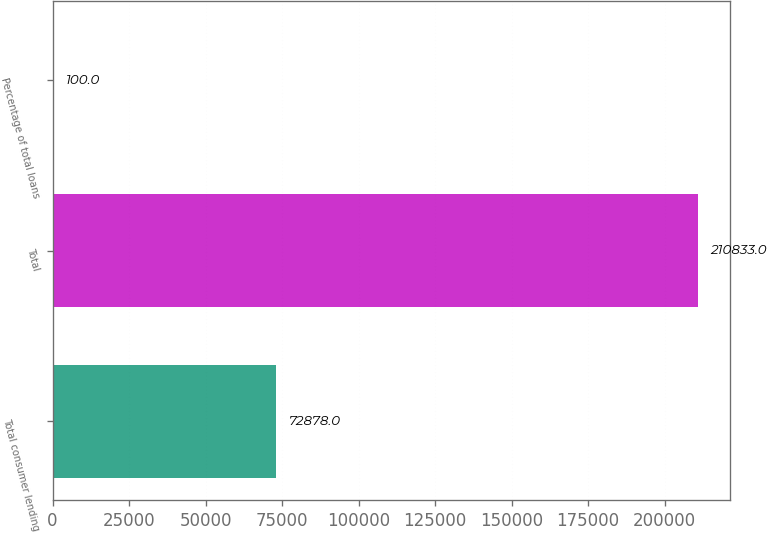Convert chart to OTSL. <chart><loc_0><loc_0><loc_500><loc_500><bar_chart><fcel>Total consumer lending<fcel>Total<fcel>Percentage of total loans<nl><fcel>72878<fcel>210833<fcel>100<nl></chart> 